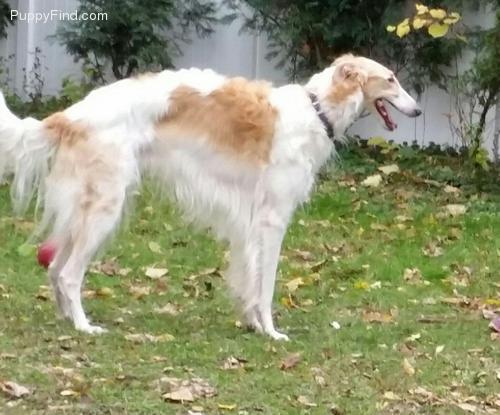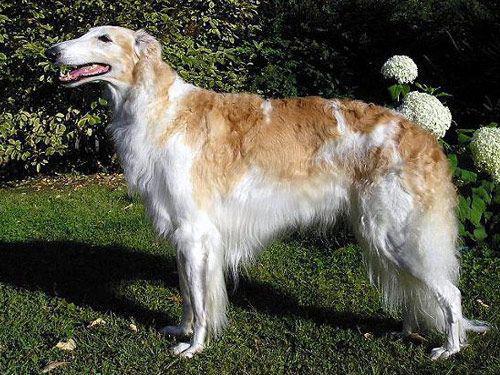The first image is the image on the left, the second image is the image on the right. Evaluate the accuracy of this statement regarding the images: "The dogs in the image on the left are facing right.". Is it true? Answer yes or no. Yes. 